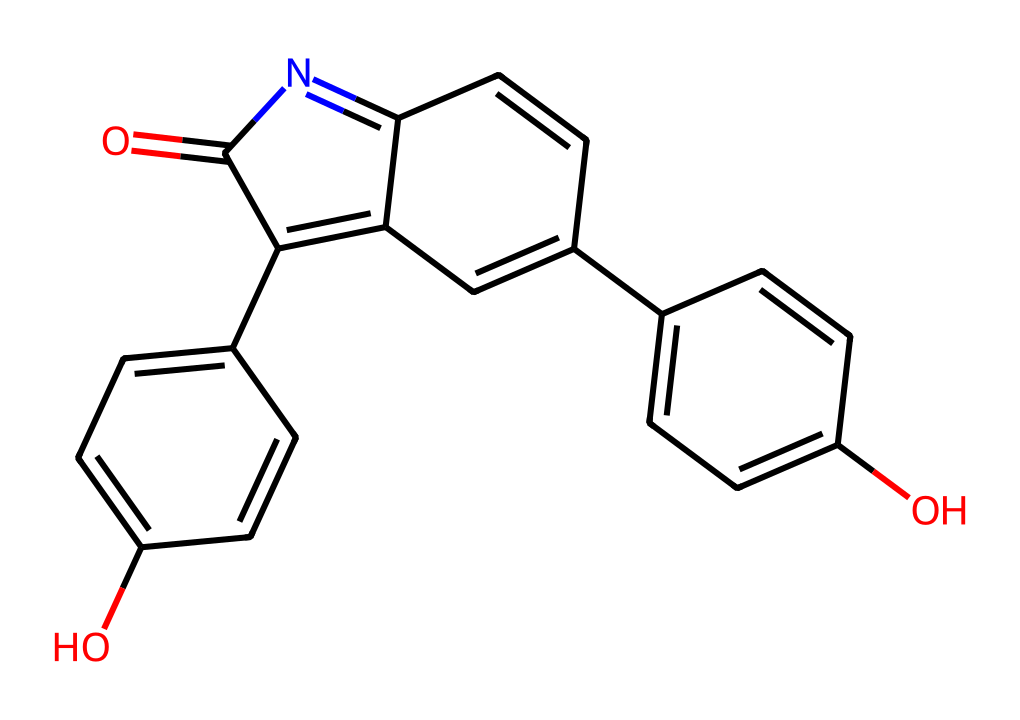What is the main functional group present in this chemical? The structure shows a carbonyl group (C=O) and multiple hydroxyl groups (–OH), indicating they are key functional groups.
Answer: carbonyl and hydroxyl How many aromatic rings are present in this structure? Analyzing the structure, there are four distinct aromatic rings evident due to the alternating double bonds in their cycles.
Answer: four What type of chemical reaction is likely utilized to modify this dye during textile processing? The presence of functional groups such as hydroxyl indicates that esterification or other modifications involving reactions with alcohols may occur in the dyeing process.
Answer: esterification What is the molecular formula derived from the SMILES representation? By interpreting the SMILES, we can summarize the atoms present, yielding a molecular formula such as C16H14N2O4 from counting carbon, hydrogen, nitrogen, and oxygen atoms.
Answer: C16H14N2O4 Does this compound exhibit properties typical of Non-Newtonian fluids? The presence of large non-linear structures and varying viscosity with shear stress indicates it behaves according to Non-Newtonian fluid characteristics, mainly due to its polymeric nature.
Answer: Yes 